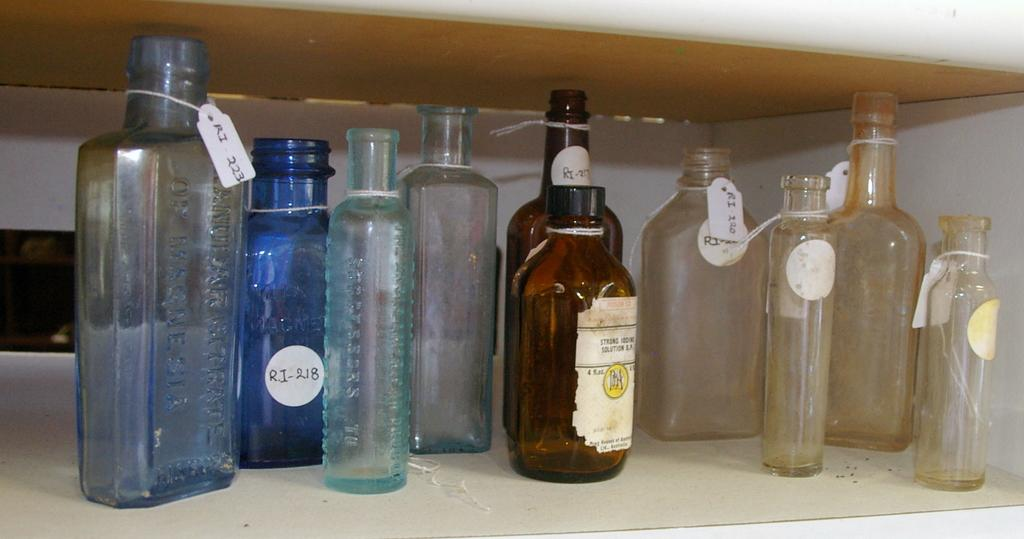<image>
Provide a brief description of the given image. a blue bottle with RJ 18 on it 